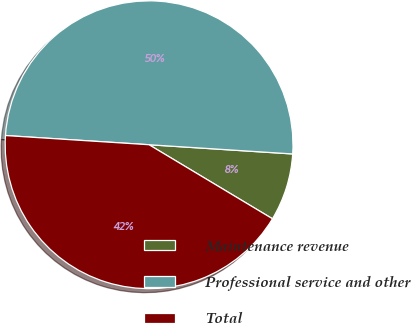Convert chart. <chart><loc_0><loc_0><loc_500><loc_500><pie_chart><fcel>Maintenance revenue<fcel>Professional service and other<fcel>Total<nl><fcel>7.58%<fcel>50.0%<fcel>42.42%<nl></chart> 